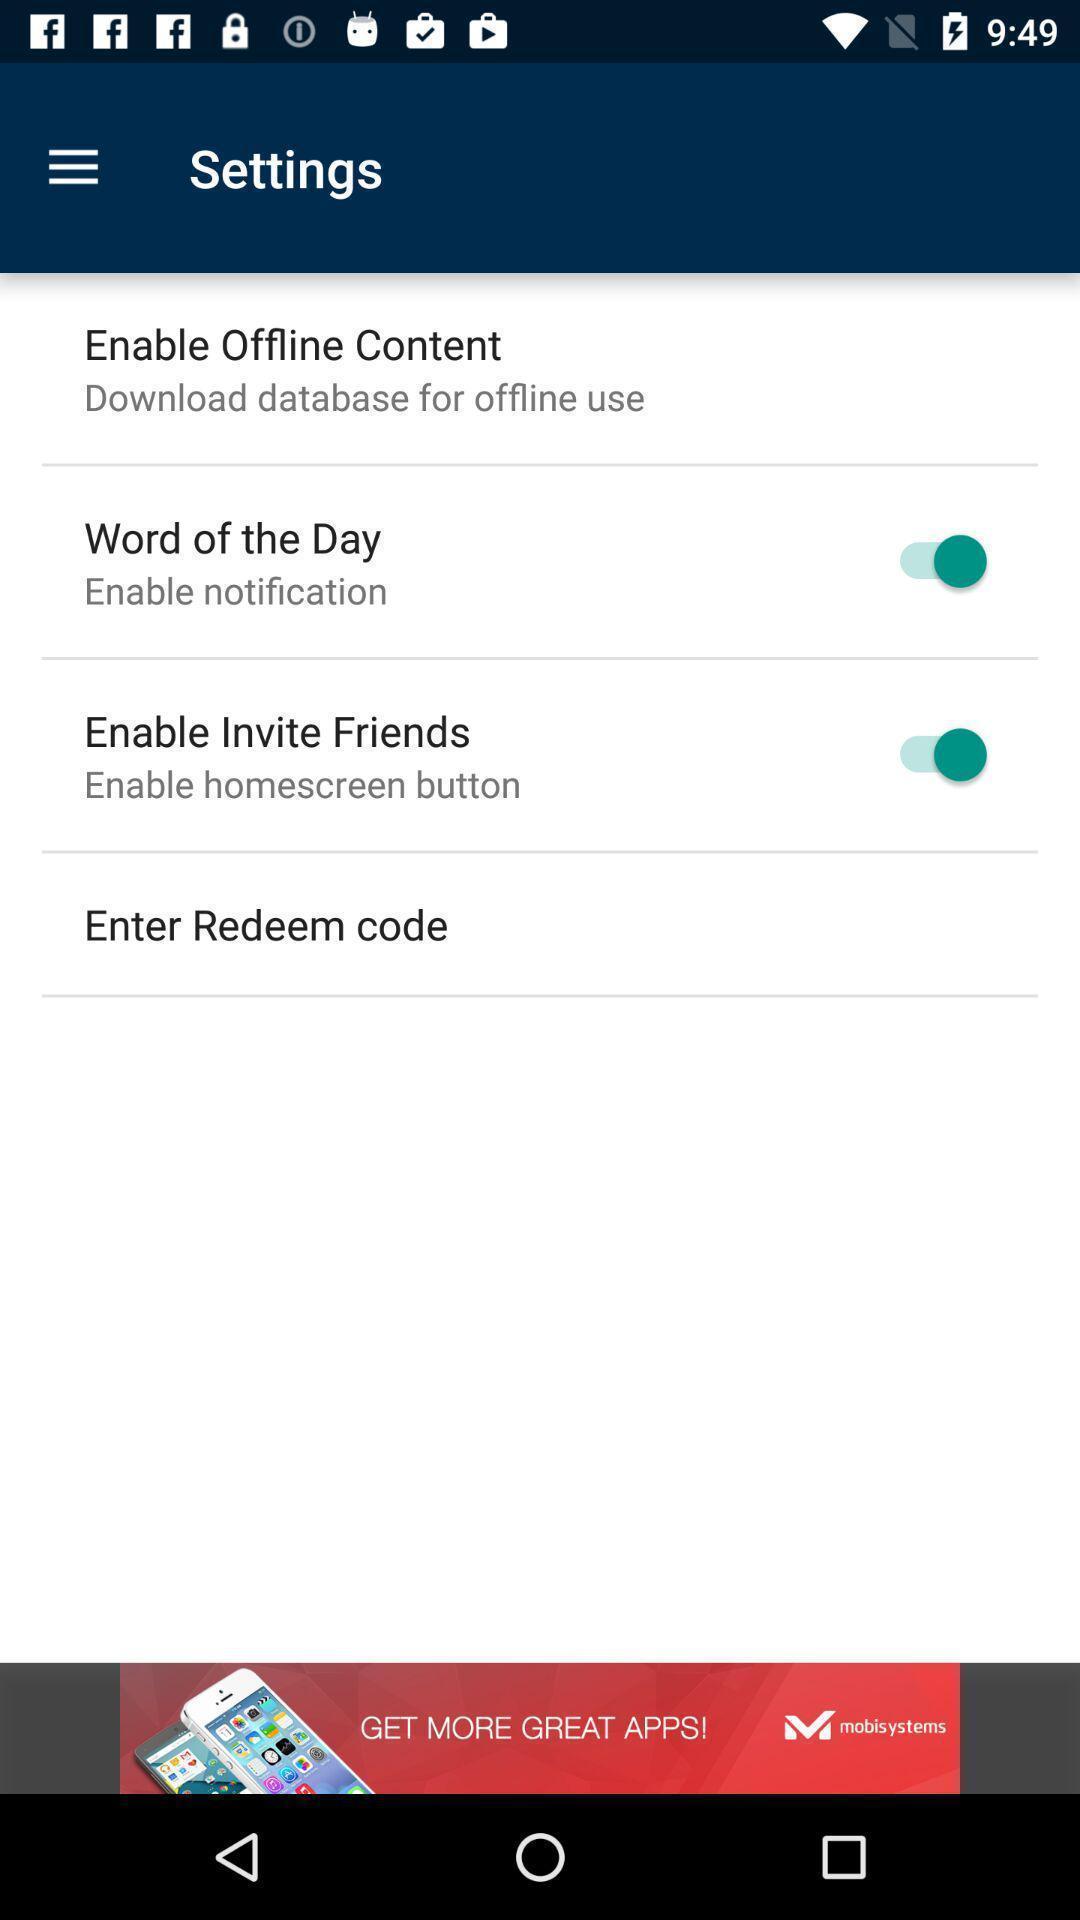What is the overall content of this screenshot? Settings page with various options. 